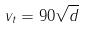<formula> <loc_0><loc_0><loc_500><loc_500>v _ { t } = 9 0 \sqrt { d }</formula> 